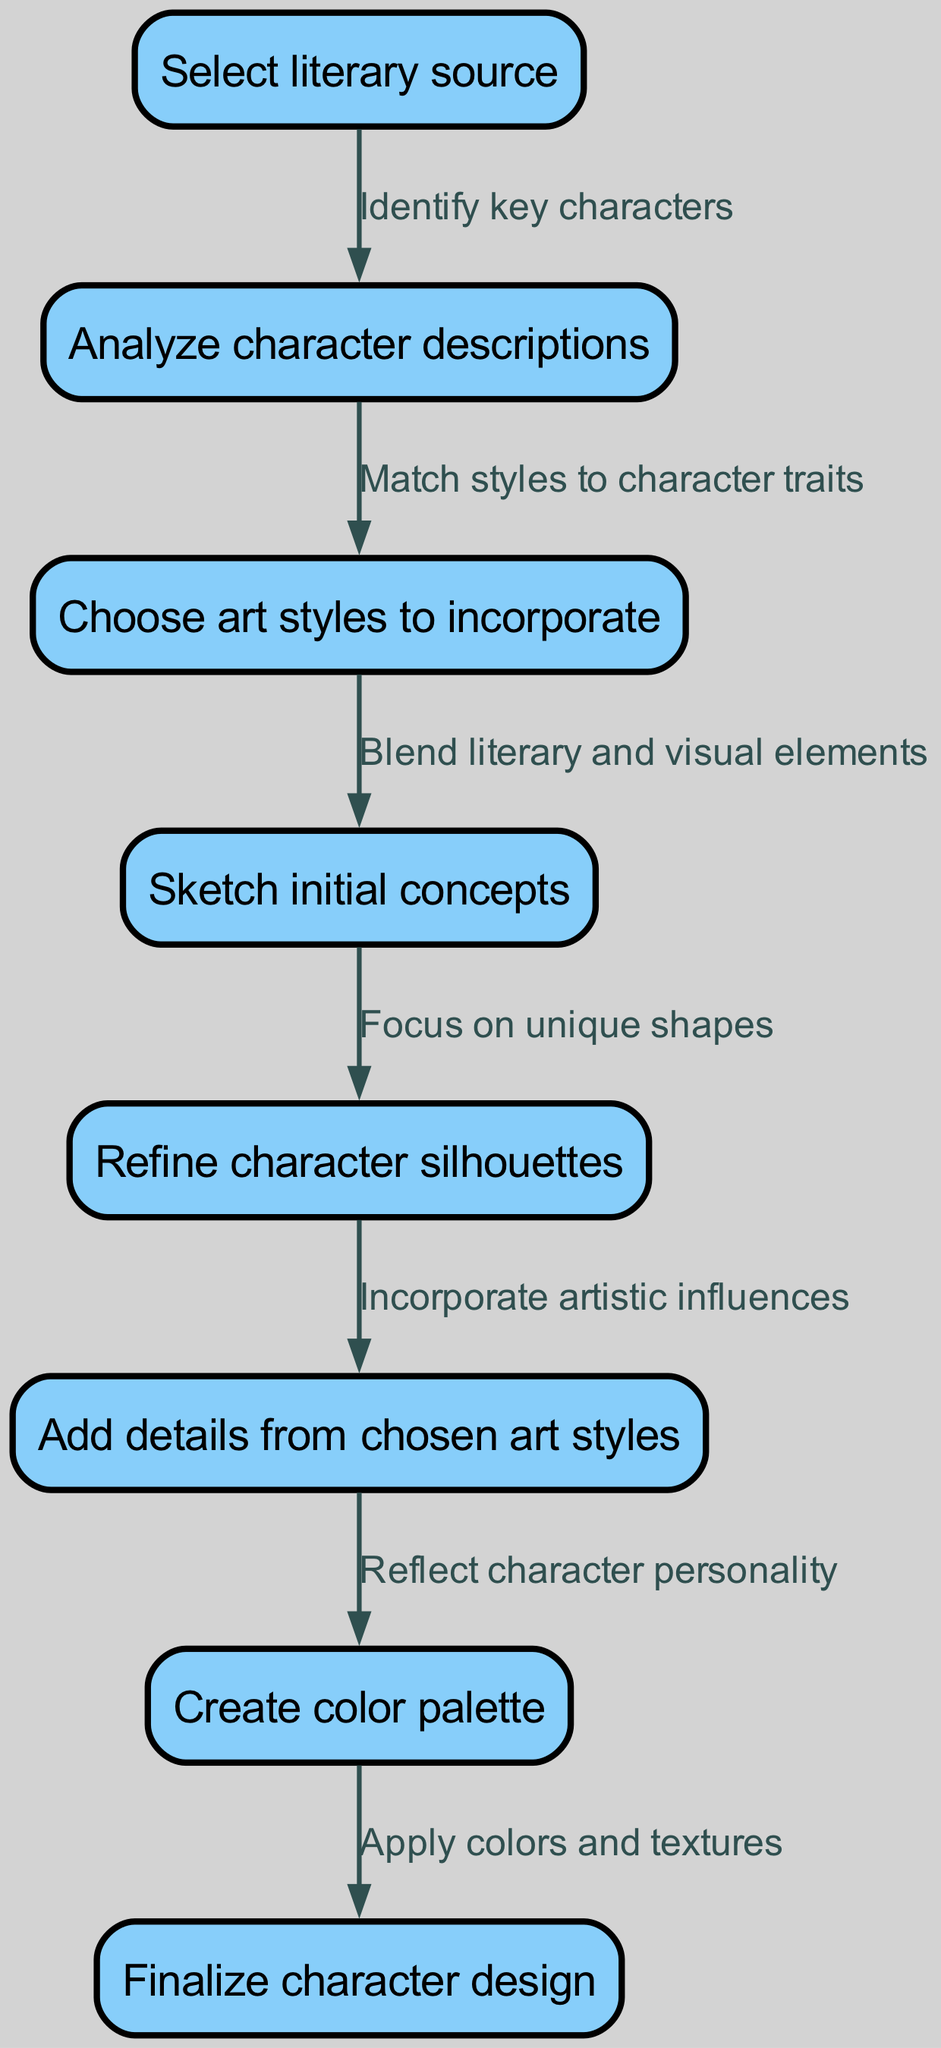What is the starting point of the diagram? The diagram begins at the first node labeled "Select literary source," which is the initiating step in the creative process for character design.
Answer: Select literary source How many nodes are present in the diagram? Counting each node listed in the diagram, there are a total of eight distinct steps represented.
Answer: 8 What is the relationship between "Sketch initial concepts" and "Refine character silhouettes"? The edge from "Sketch initial concepts" to "Refine character silhouettes" indicates a workflow where after sketching is completed, the next step involves focusing on unique shapes, hence refining silhouettes.
Answer: Focus on unique shapes At which node is the color palette created? The creation of the color palette occurs at the seventh node in the flowchart, specifically after incorporating artistic influences into the character design.
Answer: Create color palette Which node links "Analyze character descriptions" and "Choose art styles to incorporate"? The edge connecting these two nodes indicates the action of "Match styles to character traits," showing the reasoning for selecting art styles based on literary character descriptions.
Answer: Match styles to character traits What are the final steps in the creative process flowchart? The last two nodes show that after creating a color palette, the finalization of the character design occurs, applying colors and textures to complete the design.
Answer: Apply colors and textures Which node involves adding details from the chosen art styles? The sixth node is dedicated to this action, highlighting the importance of integrating specific artistic influences into the character's design after refining shapes.
Answer: Add details from chosen art styles What step comes immediately after "Choose art styles to incorporate"? The diagram shows that the next action taken after choosing art styles is to begin sketching initial concepts that blend these influences with the literary elements.
Answer: Sketch initial concepts 